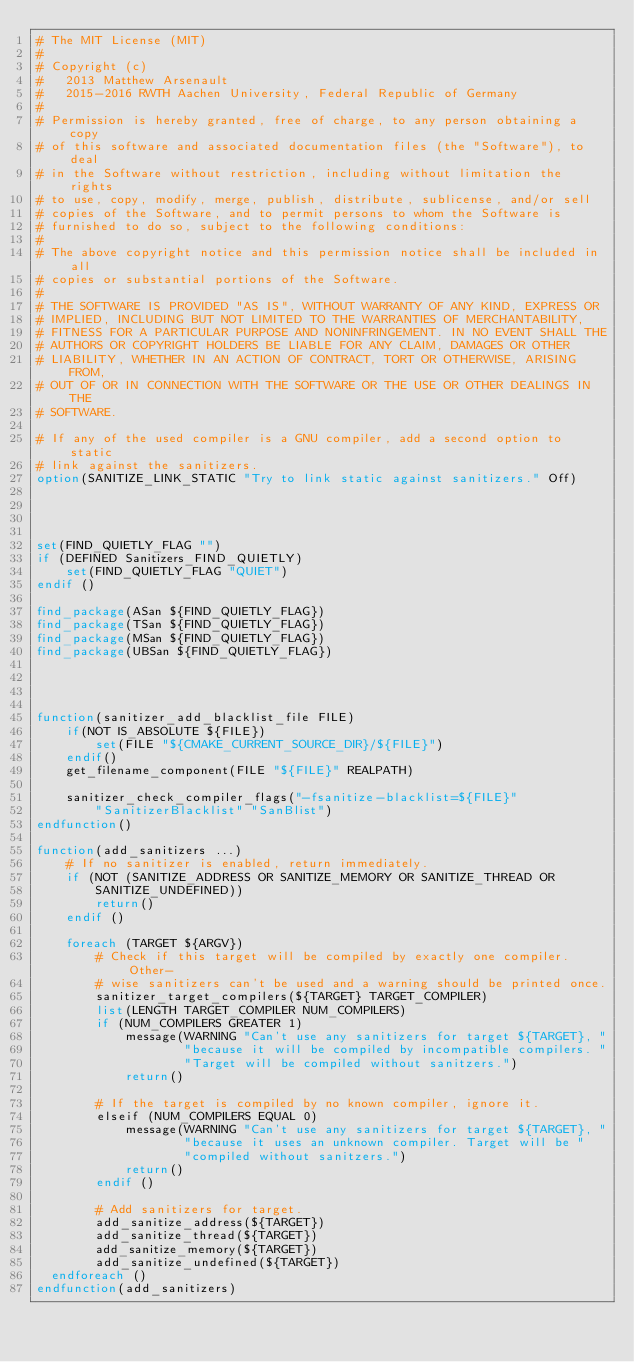Convert code to text. <code><loc_0><loc_0><loc_500><loc_500><_CMake_># The MIT License (MIT)
#
# Copyright (c)
#   2013 Matthew Arsenault
#   2015-2016 RWTH Aachen University, Federal Republic of Germany
#
# Permission is hereby granted, free of charge, to any person obtaining a copy
# of this software and associated documentation files (the "Software"), to deal
# in the Software without restriction, including without limitation the rights
# to use, copy, modify, merge, publish, distribute, sublicense, and/or sell
# copies of the Software, and to permit persons to whom the Software is
# furnished to do so, subject to the following conditions:
#
# The above copyright notice and this permission notice shall be included in all
# copies or substantial portions of the Software.
#
# THE SOFTWARE IS PROVIDED "AS IS", WITHOUT WARRANTY OF ANY KIND, EXPRESS OR
# IMPLIED, INCLUDING BUT NOT LIMITED TO THE WARRANTIES OF MERCHANTABILITY,
# FITNESS FOR A PARTICULAR PURPOSE AND NONINFRINGEMENT. IN NO EVENT SHALL THE
# AUTHORS OR COPYRIGHT HOLDERS BE LIABLE FOR ANY CLAIM, DAMAGES OR OTHER
# LIABILITY, WHETHER IN AN ACTION OF CONTRACT, TORT OR OTHERWISE, ARISING FROM,
# OUT OF OR IN CONNECTION WITH THE SOFTWARE OR THE USE OR OTHER DEALINGS IN THE
# SOFTWARE.

# If any of the used compiler is a GNU compiler, add a second option to static
# link against the sanitizers.
option(SANITIZE_LINK_STATIC "Try to link static against sanitizers." Off)




set(FIND_QUIETLY_FLAG "")
if (DEFINED Sanitizers_FIND_QUIETLY)
    set(FIND_QUIETLY_FLAG "QUIET")
endif ()

find_package(ASan ${FIND_QUIETLY_FLAG})
find_package(TSan ${FIND_QUIETLY_FLAG})
find_package(MSan ${FIND_QUIETLY_FLAG})
find_package(UBSan ${FIND_QUIETLY_FLAG})




function(sanitizer_add_blacklist_file FILE)
    if(NOT IS_ABSOLUTE ${FILE})
        set(FILE "${CMAKE_CURRENT_SOURCE_DIR}/${FILE}")
    endif()
    get_filename_component(FILE "${FILE}" REALPATH)

    sanitizer_check_compiler_flags("-fsanitize-blacklist=${FILE}"
        "SanitizerBlacklist" "SanBlist")
endfunction()

function(add_sanitizers ...)
    # If no sanitizer is enabled, return immediately.
    if (NOT (SANITIZE_ADDRESS OR SANITIZE_MEMORY OR SANITIZE_THREAD OR
        SANITIZE_UNDEFINED))
        return()
    endif ()

    foreach (TARGET ${ARGV})
        # Check if this target will be compiled by exactly one compiler. Other-
        # wise sanitizers can't be used and a warning should be printed once.
        sanitizer_target_compilers(${TARGET} TARGET_COMPILER)
        list(LENGTH TARGET_COMPILER NUM_COMPILERS)
        if (NUM_COMPILERS GREATER 1)
            message(WARNING "Can't use any sanitizers for target ${TARGET}, "
                    "because it will be compiled by incompatible compilers. "
                    "Target will be compiled without sanitzers.")
            return()

        # If the target is compiled by no known compiler, ignore it.
        elseif (NUM_COMPILERS EQUAL 0)
            message(WARNING "Can't use any sanitizers for target ${TARGET}, "
                    "because it uses an unknown compiler. Target will be "
                    "compiled without sanitzers.")
            return()
        endif ()

        # Add sanitizers for target.
        add_sanitize_address(${TARGET})
        add_sanitize_thread(${TARGET})
        add_sanitize_memory(${TARGET})
        add_sanitize_undefined(${TARGET})
	endforeach ()
endfunction(add_sanitizers)
</code> 